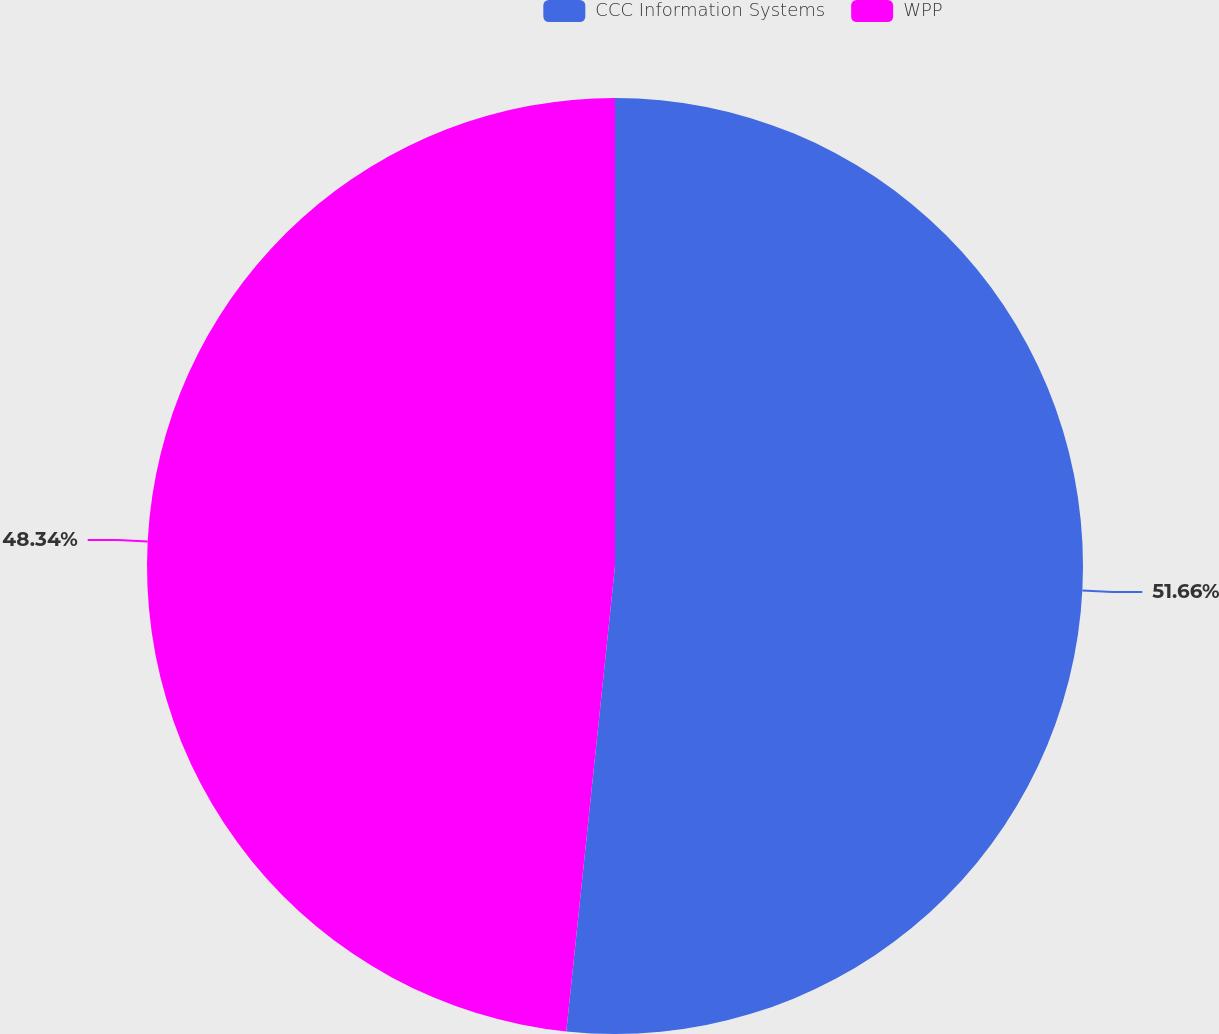Convert chart. <chart><loc_0><loc_0><loc_500><loc_500><pie_chart><fcel>CCC Information Systems<fcel>WPP<nl><fcel>51.66%<fcel>48.34%<nl></chart> 